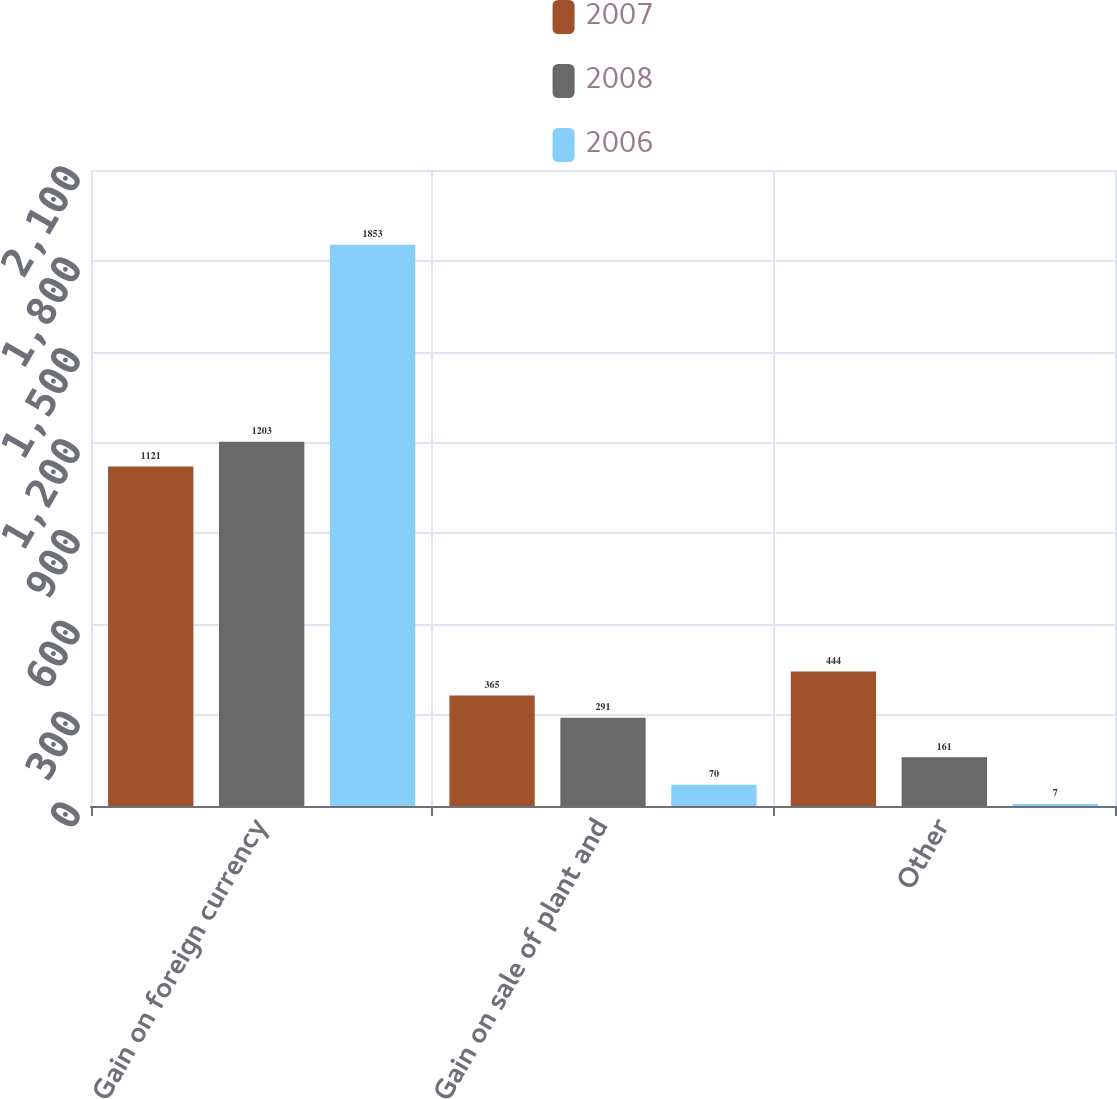Convert chart to OTSL. <chart><loc_0><loc_0><loc_500><loc_500><stacked_bar_chart><ecel><fcel>Gain on foreign currency<fcel>Gain on sale of plant and<fcel>Other<nl><fcel>2007<fcel>1121<fcel>365<fcel>444<nl><fcel>2008<fcel>1203<fcel>291<fcel>161<nl><fcel>2006<fcel>1853<fcel>70<fcel>7<nl></chart> 